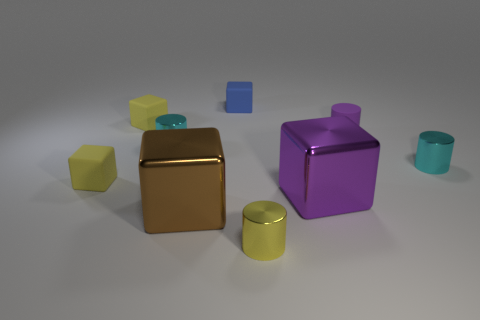Are there fewer metallic blocks behind the big brown block than purple objects that are behind the tiny yellow metallic cylinder?
Provide a short and direct response. Yes. What is the shape of the cyan object that is on the left side of the small blue object?
Your response must be concise. Cylinder. How many other objects are there of the same material as the blue thing?
Your response must be concise. 3. Is the shape of the purple metal thing the same as the big object that is on the left side of the yellow metal object?
Provide a succinct answer. Yes. There is a purple thing that is the same material as the tiny blue object; what is its shape?
Give a very brief answer. Cylinder. Is the number of tiny matte cylinders in front of the blue block greater than the number of purple things on the left side of the small yellow cylinder?
Ensure brevity in your answer.  Yes. What number of objects are either tiny purple matte cylinders or purple metal things?
Provide a succinct answer. 2. What number of other things are the same color as the rubber cylinder?
Offer a terse response. 1. There is a purple object that is the same size as the yellow cylinder; what is its shape?
Offer a terse response. Cylinder. What is the color of the large cube on the left side of the small yellow cylinder?
Give a very brief answer. Brown. 